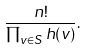<formula> <loc_0><loc_0><loc_500><loc_500>\frac { n ! } { \prod _ { v \in S } h ( v ) } .</formula> 